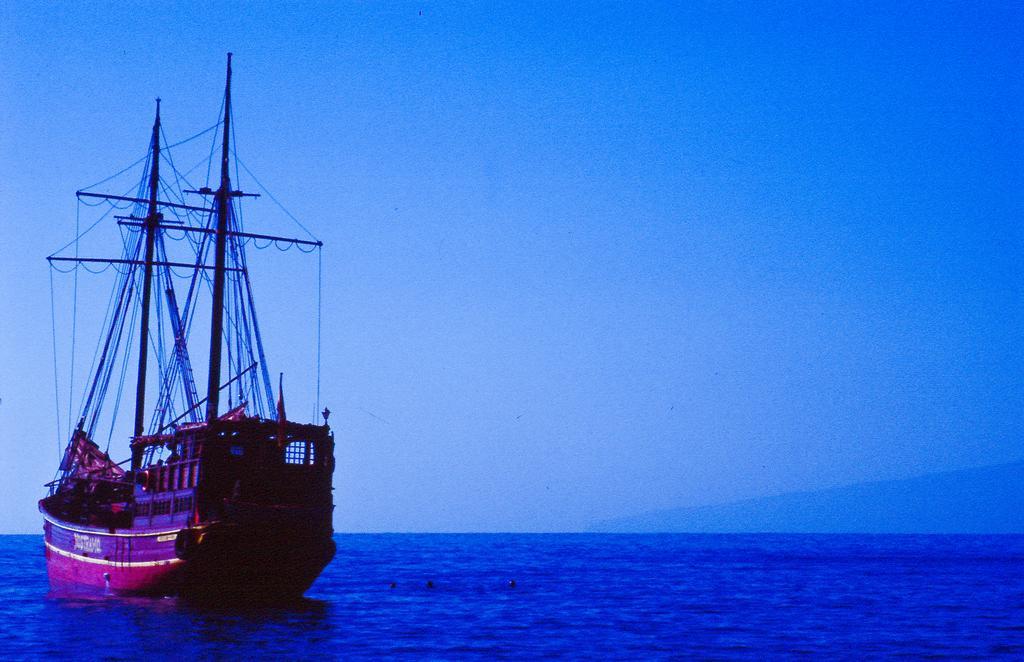Describe this image in one or two sentences. In this image I see a boat over here and I see many wires to the poles and I see the water. In the background I see the sky. 